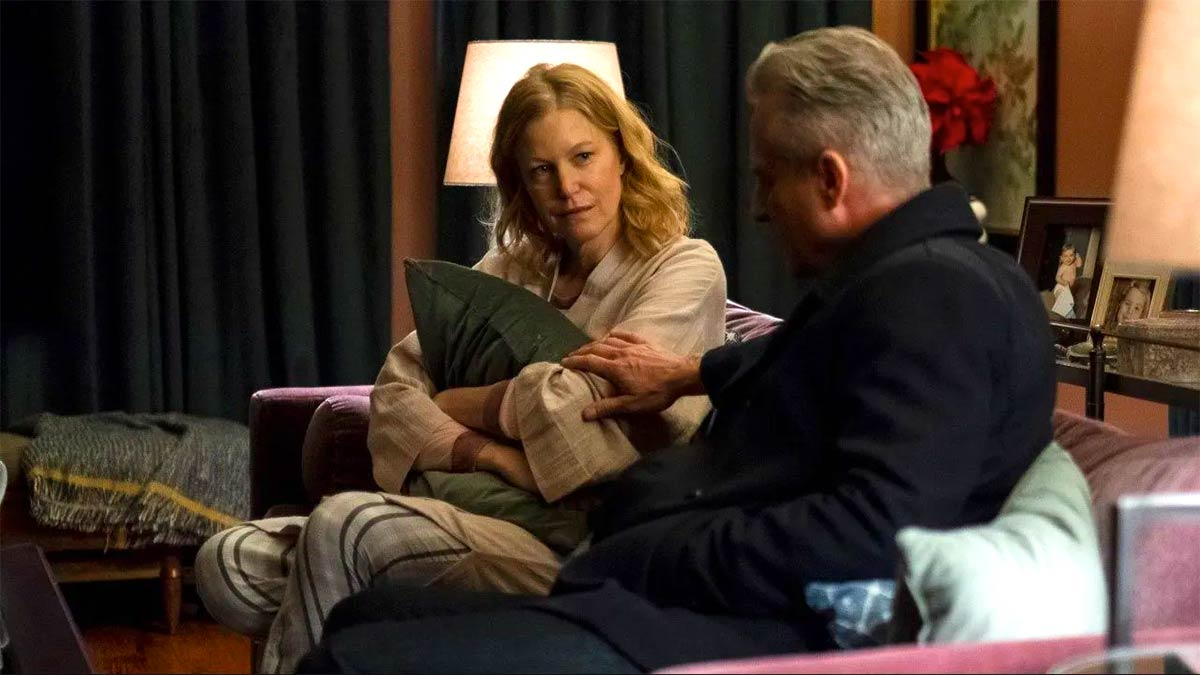Could you create a fantastical story involving the characters and setting in this image? In a world where magic and reality intertwine, Sarah and Mark are not your everyday individuals but Guardians of the Hearth. Their cozy living room is a haven, a magical sanctuary that protects an ancient artifact known as the Heartstone. This artifact holds the power to maintain balance and peace in their mystical realm.

Tonight, Sarah, the Keeper of the Heartstone, is troubled. The artifact has been showing signs of distress, glowing faintly as if its power is waning. Mark, her brother and the Protector of the Realm, listens intently. He knows that the Heartstone's weakening could spell disaster for their world.

'Sarah, we must act quickly,' Mark says with urgency. 'The Heartstone is connected to the very life force of our realm. If it fades, we risk losing everything.'

Sarah clutches the green pillow, which is enchanted and holds a fragment of the Heartstone's magic. 'I can feel its pain, Mark. But what can we do? The Dark Forces are growing stronger each day.'

Mark's eyes blaze with determination. 'We will venture into the Forbidden Forest and seek the Elder Tree. It knows the old magic, and it may have the knowledge we need to restore the Heartstone.'

With a plan in motion, the two siblings prepare for their perilous journey, leaving their warm, enchanted haven to face the unknown challenges ahead. Their bond and bravery might be the only things standing between their world and eternal darkness. 